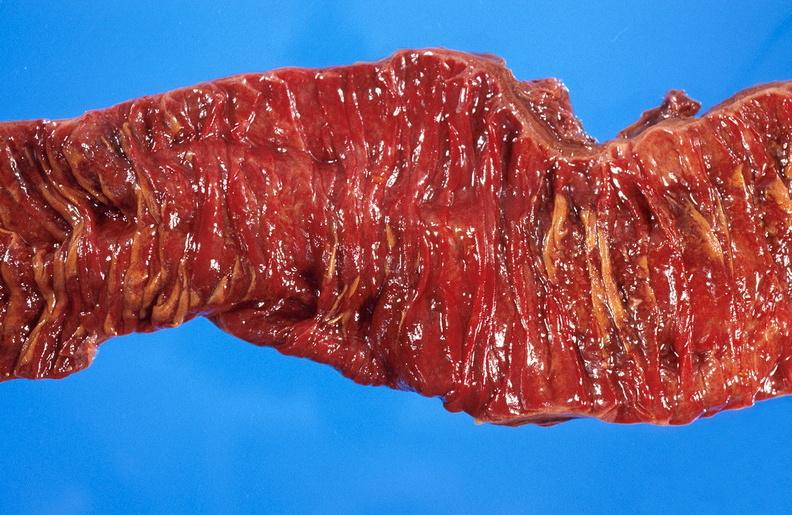what is present?
Answer the question using a single word or phrase. Gastrointestinal 